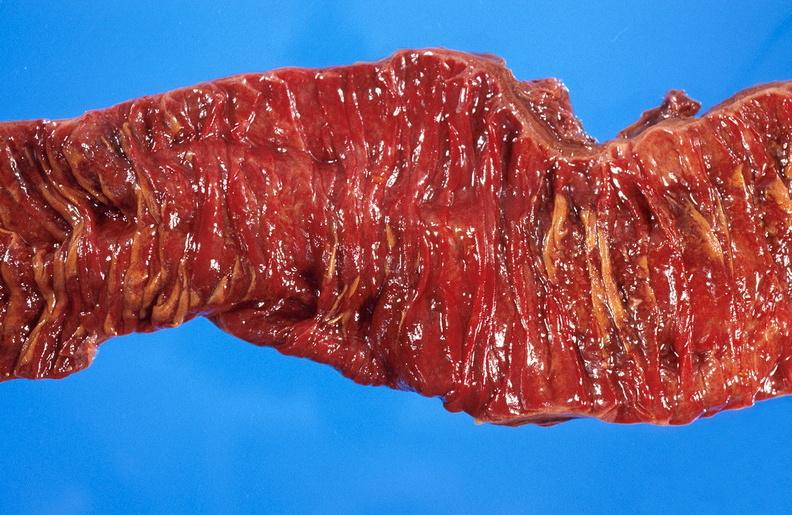what is present?
Answer the question using a single word or phrase. Gastrointestinal 